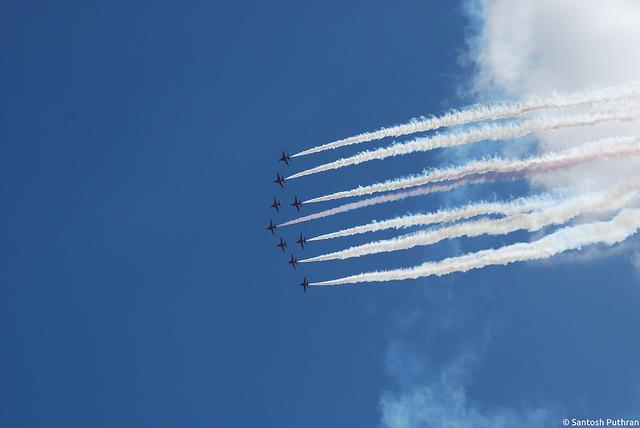What is the white trail behind the plane called?

Choices:
A) banner
B) net
C) cloud
D) contrail contrail 